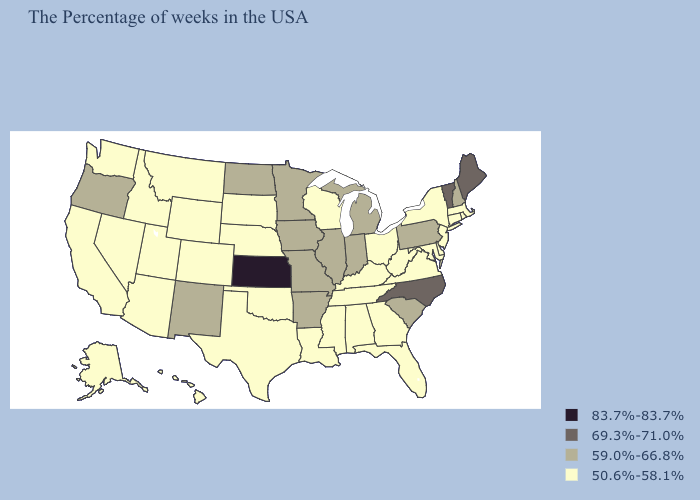Does the map have missing data?
Write a very short answer. No. Name the states that have a value in the range 69.3%-71.0%?
Short answer required. Maine, Vermont, North Carolina. Is the legend a continuous bar?
Quick response, please. No. Does Oklahoma have a lower value than Idaho?
Give a very brief answer. No. Name the states that have a value in the range 50.6%-58.1%?
Short answer required. Massachusetts, Rhode Island, Connecticut, New York, New Jersey, Delaware, Maryland, Virginia, West Virginia, Ohio, Florida, Georgia, Kentucky, Alabama, Tennessee, Wisconsin, Mississippi, Louisiana, Nebraska, Oklahoma, Texas, South Dakota, Wyoming, Colorado, Utah, Montana, Arizona, Idaho, Nevada, California, Washington, Alaska, Hawaii. Which states have the lowest value in the USA?
Keep it brief. Massachusetts, Rhode Island, Connecticut, New York, New Jersey, Delaware, Maryland, Virginia, West Virginia, Ohio, Florida, Georgia, Kentucky, Alabama, Tennessee, Wisconsin, Mississippi, Louisiana, Nebraska, Oklahoma, Texas, South Dakota, Wyoming, Colorado, Utah, Montana, Arizona, Idaho, Nevada, California, Washington, Alaska, Hawaii. What is the value of Vermont?
Short answer required. 69.3%-71.0%. What is the value of Washington?
Short answer required. 50.6%-58.1%. Name the states that have a value in the range 69.3%-71.0%?
Answer briefly. Maine, Vermont, North Carolina. Name the states that have a value in the range 69.3%-71.0%?
Write a very short answer. Maine, Vermont, North Carolina. How many symbols are there in the legend?
Keep it brief. 4. Name the states that have a value in the range 83.7%-83.7%?
Be succinct. Kansas. Among the states that border Connecticut , which have the highest value?
Be succinct. Massachusetts, Rhode Island, New York. What is the lowest value in the USA?
Keep it brief. 50.6%-58.1%. 